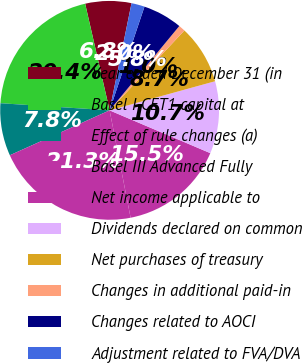Convert chart. <chart><loc_0><loc_0><loc_500><loc_500><pie_chart><fcel>Year ended December 31 (in<fcel>Basel I CET1 capital at<fcel>Effect of rule changes (a)<fcel>Basel III Advanced Fully<fcel>Net income applicable to<fcel>Dividends declared on common<fcel>Net purchases of treasury<fcel>Changes in additional paid-in<fcel>Changes related to AOCI<fcel>Adjustment related to FVA/DVA<nl><fcel>6.8%<fcel>20.37%<fcel>7.77%<fcel>21.34%<fcel>15.53%<fcel>10.68%<fcel>8.74%<fcel>0.98%<fcel>5.83%<fcel>1.95%<nl></chart> 